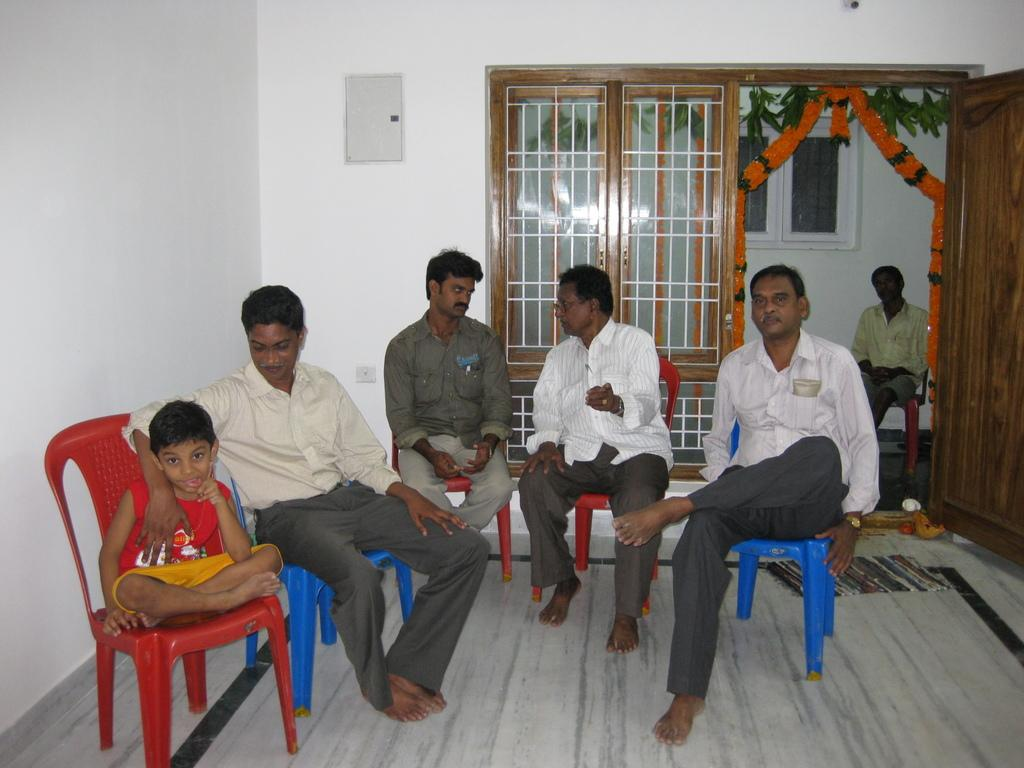How many people are in the image? There is a group of people in the image. What are the people doing in the image? The people are sitting on chairs. What can be seen through the windows in the image? The presence of windows suggests that there might be a view or outdoor scenery visible, but the specifics are not mentioned in the facts. What is the purpose of the door in the image? The door is likely a means of entering or exiting the room or space where the people are sitting. What decorative elements are present near the door? Flowers are near the door. What type of attraction can be seen near the door in the image? There is no attraction mentioned or visible in the image; it only features a group of people sitting on chairs, windows, a door, and flowers. 